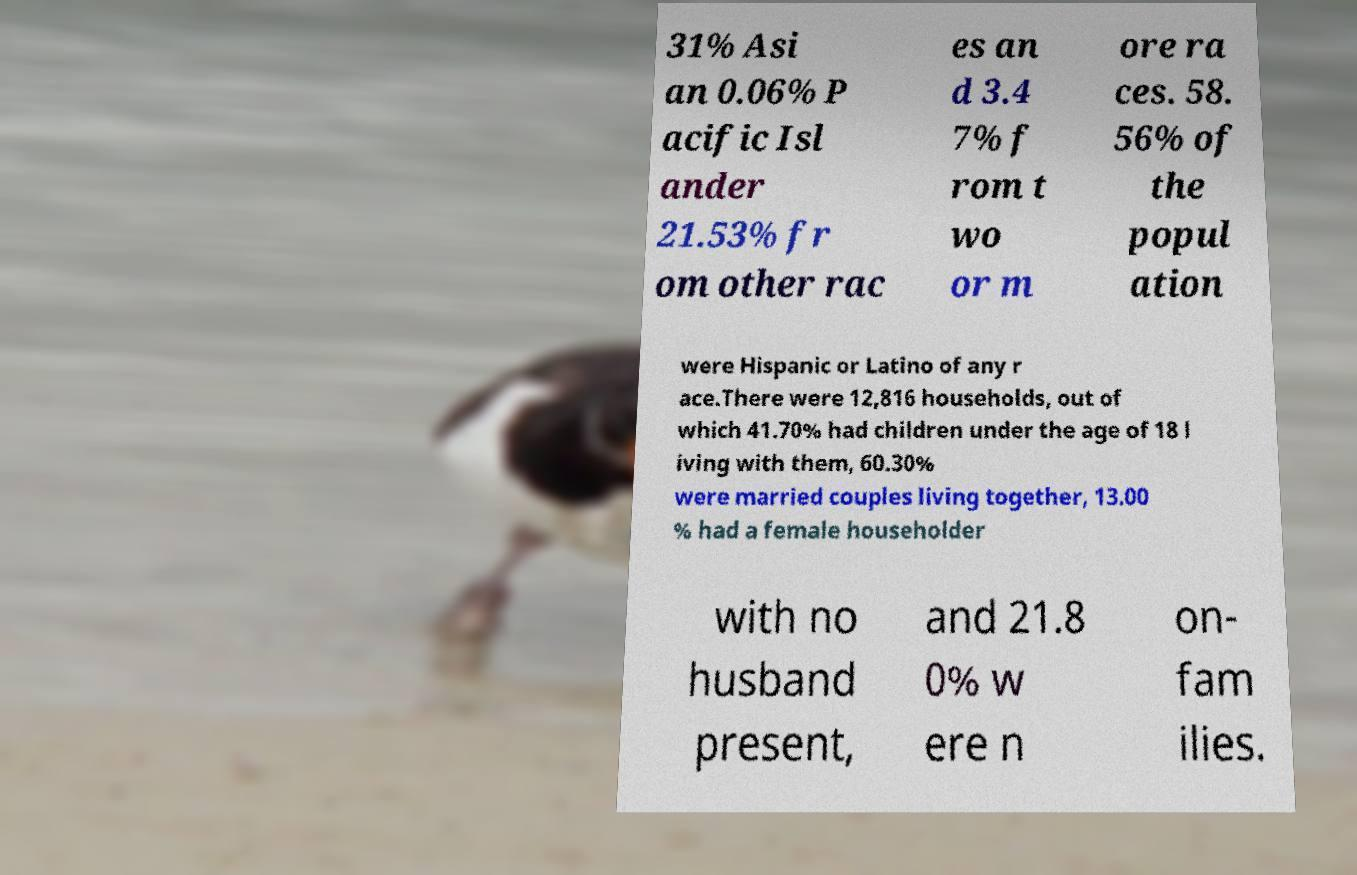For documentation purposes, I need the text within this image transcribed. Could you provide that? 31% Asi an 0.06% P acific Isl ander 21.53% fr om other rac es an d 3.4 7% f rom t wo or m ore ra ces. 58. 56% of the popul ation were Hispanic or Latino of any r ace.There were 12,816 households, out of which 41.70% had children under the age of 18 l iving with them, 60.30% were married couples living together, 13.00 % had a female householder with no husband present, and 21.8 0% w ere n on- fam ilies. 